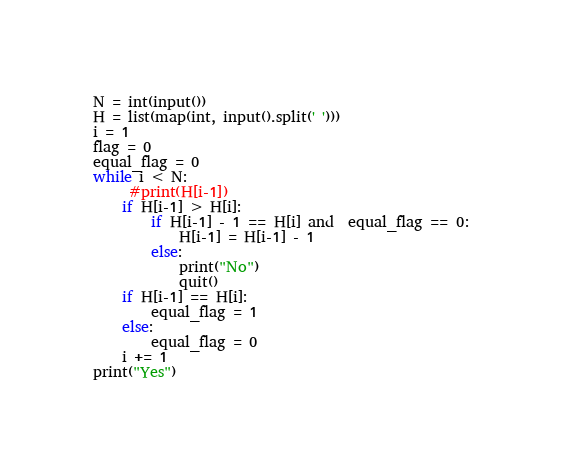Convert code to text. <code><loc_0><loc_0><loc_500><loc_500><_Python_>N = int(input())
H = list(map(int, input().split(' ')))
i = 1
flag = 0
equal_flag = 0
while i < N:
     #print(H[i-1])
    if H[i-1] > H[i]:
        if H[i-1] - 1 == H[i] and  equal_flag == 0:
            H[i-1] = H[i-1] - 1
        else:
            print("No")
            quit()
    if H[i-1] == H[i]:
        equal_flag = 1
    else:
        equal_flag = 0
    i += 1
print("Yes")</code> 